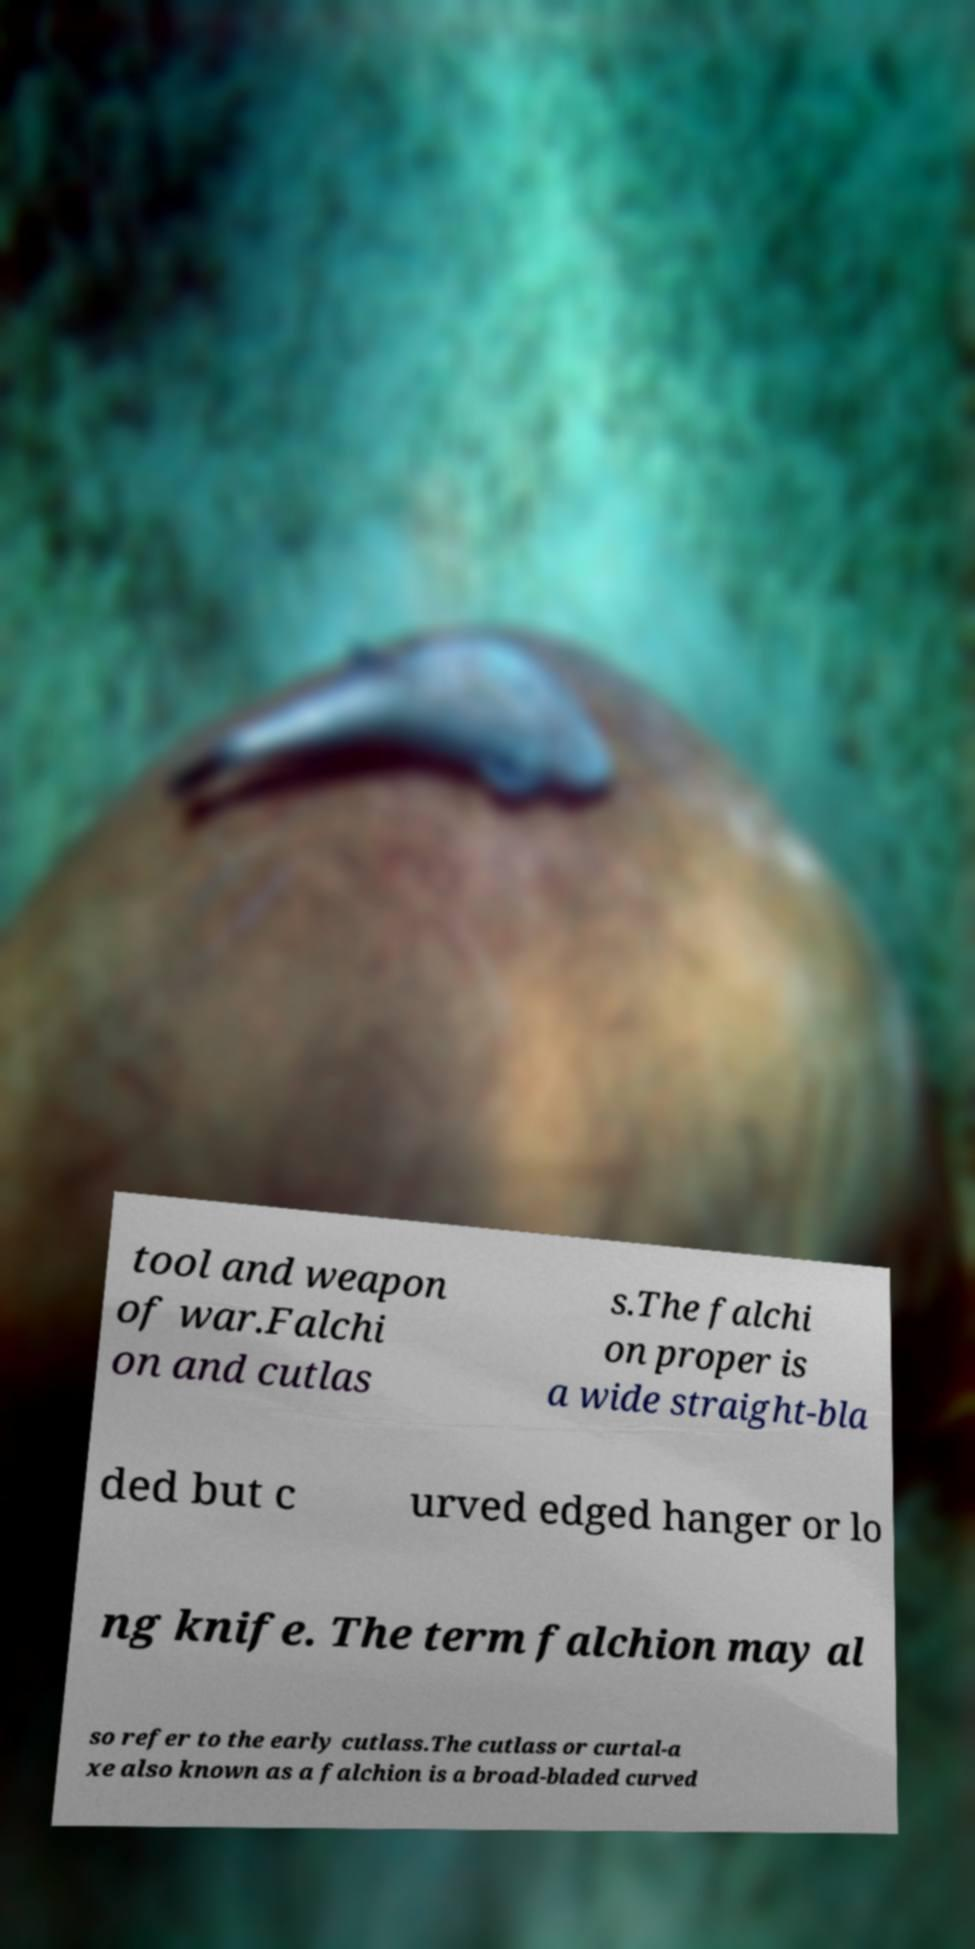There's text embedded in this image that I need extracted. Can you transcribe it verbatim? tool and weapon of war.Falchi on and cutlas s.The falchi on proper is a wide straight-bla ded but c urved edged hanger or lo ng knife. The term falchion may al so refer to the early cutlass.The cutlass or curtal-a xe also known as a falchion is a broad-bladed curved 